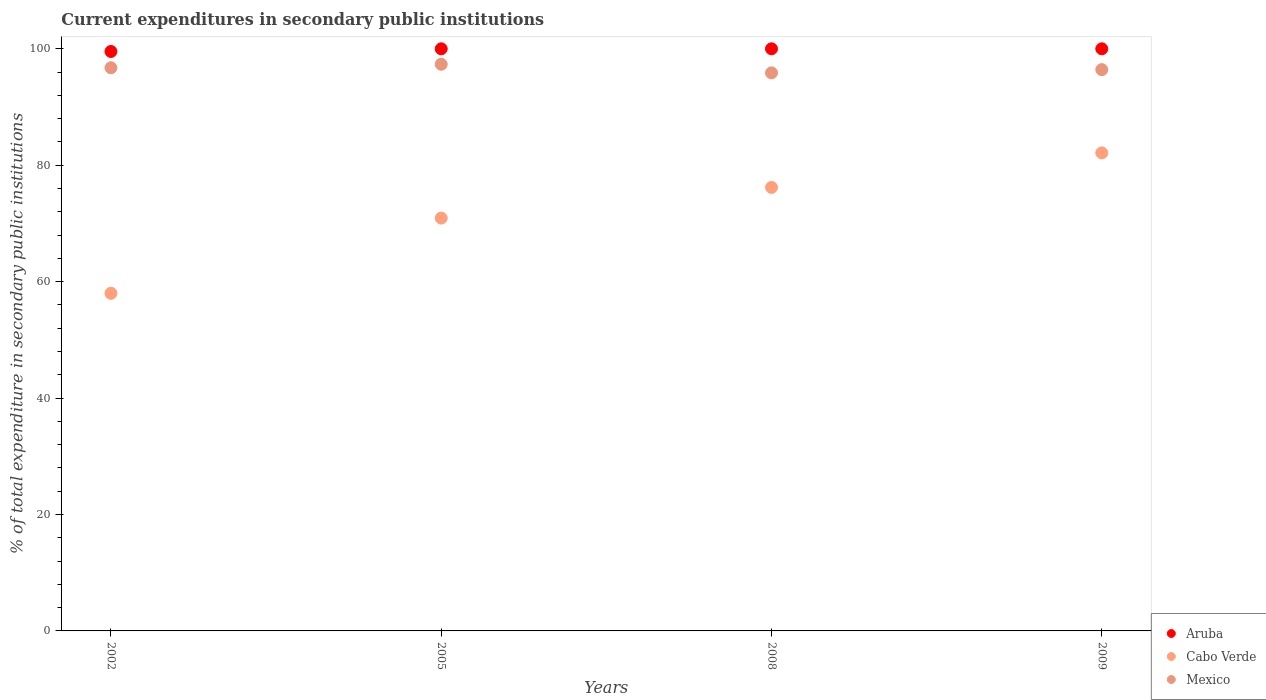Is the number of dotlines equal to the number of legend labels?
Provide a succinct answer. Yes. What is the current expenditures in secondary public institutions in Mexico in 2005?
Make the answer very short. 97.34. Across all years, what is the maximum current expenditures in secondary public institutions in Aruba?
Your response must be concise. 100. Across all years, what is the minimum current expenditures in secondary public institutions in Aruba?
Offer a terse response. 99.54. In which year was the current expenditures in secondary public institutions in Cabo Verde maximum?
Give a very brief answer. 2009. In which year was the current expenditures in secondary public institutions in Aruba minimum?
Ensure brevity in your answer.  2002. What is the total current expenditures in secondary public institutions in Cabo Verde in the graph?
Your answer should be very brief. 287.23. What is the difference between the current expenditures in secondary public institutions in Cabo Verde in 2002 and that in 2005?
Offer a terse response. -12.93. What is the difference between the current expenditures in secondary public institutions in Mexico in 2005 and the current expenditures in secondary public institutions in Cabo Verde in 2008?
Offer a very short reply. 21.16. What is the average current expenditures in secondary public institutions in Aruba per year?
Offer a terse response. 99.89. In the year 2008, what is the difference between the current expenditures in secondary public institutions in Aruba and current expenditures in secondary public institutions in Cabo Verde?
Make the answer very short. 23.81. What is the ratio of the current expenditures in secondary public institutions in Aruba in 2002 to that in 2005?
Your answer should be very brief. 1. What is the difference between the highest and the lowest current expenditures in secondary public institutions in Aruba?
Give a very brief answer. 0.46. In how many years, is the current expenditures in secondary public institutions in Aruba greater than the average current expenditures in secondary public institutions in Aruba taken over all years?
Your answer should be compact. 3. Is the sum of the current expenditures in secondary public institutions in Aruba in 2005 and 2008 greater than the maximum current expenditures in secondary public institutions in Mexico across all years?
Give a very brief answer. Yes. Is it the case that in every year, the sum of the current expenditures in secondary public institutions in Mexico and current expenditures in secondary public institutions in Cabo Verde  is greater than the current expenditures in secondary public institutions in Aruba?
Provide a short and direct response. Yes. How many years are there in the graph?
Offer a very short reply. 4. What is the difference between two consecutive major ticks on the Y-axis?
Your answer should be very brief. 20. Are the values on the major ticks of Y-axis written in scientific E-notation?
Give a very brief answer. No. Does the graph contain grids?
Provide a short and direct response. No. What is the title of the graph?
Your answer should be compact. Current expenditures in secondary public institutions. What is the label or title of the X-axis?
Offer a very short reply. Years. What is the label or title of the Y-axis?
Provide a succinct answer. % of total expenditure in secondary public institutions. What is the % of total expenditure in secondary public institutions in Aruba in 2002?
Make the answer very short. 99.54. What is the % of total expenditure in secondary public institutions in Cabo Verde in 2002?
Your answer should be compact. 58. What is the % of total expenditure in secondary public institutions in Mexico in 2002?
Offer a terse response. 96.74. What is the % of total expenditure in secondary public institutions of Aruba in 2005?
Give a very brief answer. 100. What is the % of total expenditure in secondary public institutions of Cabo Verde in 2005?
Make the answer very short. 70.92. What is the % of total expenditure in secondary public institutions of Mexico in 2005?
Offer a terse response. 97.34. What is the % of total expenditure in secondary public institutions in Cabo Verde in 2008?
Provide a succinct answer. 76.19. What is the % of total expenditure in secondary public institutions in Mexico in 2008?
Provide a short and direct response. 95.87. What is the % of total expenditure in secondary public institutions of Aruba in 2009?
Offer a very short reply. 100. What is the % of total expenditure in secondary public institutions in Cabo Verde in 2009?
Make the answer very short. 82.12. What is the % of total expenditure in secondary public institutions of Mexico in 2009?
Provide a short and direct response. 96.42. Across all years, what is the maximum % of total expenditure in secondary public institutions of Aruba?
Give a very brief answer. 100. Across all years, what is the maximum % of total expenditure in secondary public institutions of Cabo Verde?
Give a very brief answer. 82.12. Across all years, what is the maximum % of total expenditure in secondary public institutions in Mexico?
Your answer should be compact. 97.34. Across all years, what is the minimum % of total expenditure in secondary public institutions in Aruba?
Offer a terse response. 99.54. Across all years, what is the minimum % of total expenditure in secondary public institutions in Cabo Verde?
Your response must be concise. 58. Across all years, what is the minimum % of total expenditure in secondary public institutions in Mexico?
Ensure brevity in your answer.  95.87. What is the total % of total expenditure in secondary public institutions in Aruba in the graph?
Your response must be concise. 399.54. What is the total % of total expenditure in secondary public institutions in Cabo Verde in the graph?
Your answer should be compact. 287.23. What is the total % of total expenditure in secondary public institutions of Mexico in the graph?
Provide a short and direct response. 386.38. What is the difference between the % of total expenditure in secondary public institutions in Aruba in 2002 and that in 2005?
Give a very brief answer. -0.46. What is the difference between the % of total expenditure in secondary public institutions in Cabo Verde in 2002 and that in 2005?
Provide a short and direct response. -12.93. What is the difference between the % of total expenditure in secondary public institutions in Mexico in 2002 and that in 2005?
Your response must be concise. -0.6. What is the difference between the % of total expenditure in secondary public institutions in Aruba in 2002 and that in 2008?
Keep it short and to the point. -0.46. What is the difference between the % of total expenditure in secondary public institutions in Cabo Verde in 2002 and that in 2008?
Your response must be concise. -18.19. What is the difference between the % of total expenditure in secondary public institutions of Mexico in 2002 and that in 2008?
Provide a short and direct response. 0.87. What is the difference between the % of total expenditure in secondary public institutions of Aruba in 2002 and that in 2009?
Your answer should be compact. -0.46. What is the difference between the % of total expenditure in secondary public institutions of Cabo Verde in 2002 and that in 2009?
Ensure brevity in your answer.  -24.12. What is the difference between the % of total expenditure in secondary public institutions in Mexico in 2002 and that in 2009?
Your response must be concise. 0.33. What is the difference between the % of total expenditure in secondary public institutions of Cabo Verde in 2005 and that in 2008?
Give a very brief answer. -5.27. What is the difference between the % of total expenditure in secondary public institutions in Mexico in 2005 and that in 2008?
Your answer should be compact. 1.47. What is the difference between the % of total expenditure in secondary public institutions of Cabo Verde in 2005 and that in 2009?
Your answer should be compact. -11.2. What is the difference between the % of total expenditure in secondary public institutions in Mexico in 2005 and that in 2009?
Keep it short and to the point. 0.93. What is the difference between the % of total expenditure in secondary public institutions in Cabo Verde in 2008 and that in 2009?
Give a very brief answer. -5.93. What is the difference between the % of total expenditure in secondary public institutions in Mexico in 2008 and that in 2009?
Your response must be concise. -0.55. What is the difference between the % of total expenditure in secondary public institutions of Aruba in 2002 and the % of total expenditure in secondary public institutions of Cabo Verde in 2005?
Provide a succinct answer. 28.62. What is the difference between the % of total expenditure in secondary public institutions of Aruba in 2002 and the % of total expenditure in secondary public institutions of Mexico in 2005?
Make the answer very short. 2.2. What is the difference between the % of total expenditure in secondary public institutions of Cabo Verde in 2002 and the % of total expenditure in secondary public institutions of Mexico in 2005?
Offer a terse response. -39.35. What is the difference between the % of total expenditure in secondary public institutions of Aruba in 2002 and the % of total expenditure in secondary public institutions of Cabo Verde in 2008?
Offer a terse response. 23.35. What is the difference between the % of total expenditure in secondary public institutions of Aruba in 2002 and the % of total expenditure in secondary public institutions of Mexico in 2008?
Provide a succinct answer. 3.67. What is the difference between the % of total expenditure in secondary public institutions of Cabo Verde in 2002 and the % of total expenditure in secondary public institutions of Mexico in 2008?
Your answer should be compact. -37.87. What is the difference between the % of total expenditure in secondary public institutions in Aruba in 2002 and the % of total expenditure in secondary public institutions in Cabo Verde in 2009?
Offer a terse response. 17.42. What is the difference between the % of total expenditure in secondary public institutions in Aruba in 2002 and the % of total expenditure in secondary public institutions in Mexico in 2009?
Ensure brevity in your answer.  3.12. What is the difference between the % of total expenditure in secondary public institutions of Cabo Verde in 2002 and the % of total expenditure in secondary public institutions of Mexico in 2009?
Keep it short and to the point. -38.42. What is the difference between the % of total expenditure in secondary public institutions in Aruba in 2005 and the % of total expenditure in secondary public institutions in Cabo Verde in 2008?
Make the answer very short. 23.81. What is the difference between the % of total expenditure in secondary public institutions of Aruba in 2005 and the % of total expenditure in secondary public institutions of Mexico in 2008?
Provide a short and direct response. 4.13. What is the difference between the % of total expenditure in secondary public institutions in Cabo Verde in 2005 and the % of total expenditure in secondary public institutions in Mexico in 2008?
Your answer should be compact. -24.95. What is the difference between the % of total expenditure in secondary public institutions of Aruba in 2005 and the % of total expenditure in secondary public institutions of Cabo Verde in 2009?
Make the answer very short. 17.88. What is the difference between the % of total expenditure in secondary public institutions of Aruba in 2005 and the % of total expenditure in secondary public institutions of Mexico in 2009?
Provide a succinct answer. 3.58. What is the difference between the % of total expenditure in secondary public institutions in Cabo Verde in 2005 and the % of total expenditure in secondary public institutions in Mexico in 2009?
Keep it short and to the point. -25.5. What is the difference between the % of total expenditure in secondary public institutions of Aruba in 2008 and the % of total expenditure in secondary public institutions of Cabo Verde in 2009?
Your answer should be very brief. 17.88. What is the difference between the % of total expenditure in secondary public institutions in Aruba in 2008 and the % of total expenditure in secondary public institutions in Mexico in 2009?
Give a very brief answer. 3.58. What is the difference between the % of total expenditure in secondary public institutions of Cabo Verde in 2008 and the % of total expenditure in secondary public institutions of Mexico in 2009?
Provide a short and direct response. -20.23. What is the average % of total expenditure in secondary public institutions in Aruba per year?
Ensure brevity in your answer.  99.89. What is the average % of total expenditure in secondary public institutions in Cabo Verde per year?
Give a very brief answer. 71.81. What is the average % of total expenditure in secondary public institutions in Mexico per year?
Offer a terse response. 96.59. In the year 2002, what is the difference between the % of total expenditure in secondary public institutions of Aruba and % of total expenditure in secondary public institutions of Cabo Verde?
Offer a very short reply. 41.54. In the year 2002, what is the difference between the % of total expenditure in secondary public institutions in Aruba and % of total expenditure in secondary public institutions in Mexico?
Your answer should be compact. 2.8. In the year 2002, what is the difference between the % of total expenditure in secondary public institutions of Cabo Verde and % of total expenditure in secondary public institutions of Mexico?
Keep it short and to the point. -38.75. In the year 2005, what is the difference between the % of total expenditure in secondary public institutions of Aruba and % of total expenditure in secondary public institutions of Cabo Verde?
Ensure brevity in your answer.  29.08. In the year 2005, what is the difference between the % of total expenditure in secondary public institutions in Aruba and % of total expenditure in secondary public institutions in Mexico?
Offer a very short reply. 2.66. In the year 2005, what is the difference between the % of total expenditure in secondary public institutions of Cabo Verde and % of total expenditure in secondary public institutions of Mexico?
Make the answer very short. -26.42. In the year 2008, what is the difference between the % of total expenditure in secondary public institutions of Aruba and % of total expenditure in secondary public institutions of Cabo Verde?
Give a very brief answer. 23.81. In the year 2008, what is the difference between the % of total expenditure in secondary public institutions in Aruba and % of total expenditure in secondary public institutions in Mexico?
Make the answer very short. 4.13. In the year 2008, what is the difference between the % of total expenditure in secondary public institutions in Cabo Verde and % of total expenditure in secondary public institutions in Mexico?
Keep it short and to the point. -19.68. In the year 2009, what is the difference between the % of total expenditure in secondary public institutions in Aruba and % of total expenditure in secondary public institutions in Cabo Verde?
Your response must be concise. 17.88. In the year 2009, what is the difference between the % of total expenditure in secondary public institutions of Aruba and % of total expenditure in secondary public institutions of Mexico?
Keep it short and to the point. 3.58. In the year 2009, what is the difference between the % of total expenditure in secondary public institutions of Cabo Verde and % of total expenditure in secondary public institutions of Mexico?
Provide a short and direct response. -14.3. What is the ratio of the % of total expenditure in secondary public institutions in Cabo Verde in 2002 to that in 2005?
Provide a short and direct response. 0.82. What is the ratio of the % of total expenditure in secondary public institutions of Aruba in 2002 to that in 2008?
Provide a succinct answer. 1. What is the ratio of the % of total expenditure in secondary public institutions of Cabo Verde in 2002 to that in 2008?
Provide a succinct answer. 0.76. What is the ratio of the % of total expenditure in secondary public institutions in Mexico in 2002 to that in 2008?
Ensure brevity in your answer.  1.01. What is the ratio of the % of total expenditure in secondary public institutions in Aruba in 2002 to that in 2009?
Keep it short and to the point. 1. What is the ratio of the % of total expenditure in secondary public institutions of Cabo Verde in 2002 to that in 2009?
Offer a terse response. 0.71. What is the ratio of the % of total expenditure in secondary public institutions of Cabo Verde in 2005 to that in 2008?
Your answer should be compact. 0.93. What is the ratio of the % of total expenditure in secondary public institutions of Mexico in 2005 to that in 2008?
Give a very brief answer. 1.02. What is the ratio of the % of total expenditure in secondary public institutions in Aruba in 2005 to that in 2009?
Your response must be concise. 1. What is the ratio of the % of total expenditure in secondary public institutions of Cabo Verde in 2005 to that in 2009?
Your answer should be compact. 0.86. What is the ratio of the % of total expenditure in secondary public institutions of Mexico in 2005 to that in 2009?
Provide a short and direct response. 1.01. What is the ratio of the % of total expenditure in secondary public institutions of Cabo Verde in 2008 to that in 2009?
Your answer should be compact. 0.93. What is the ratio of the % of total expenditure in secondary public institutions of Mexico in 2008 to that in 2009?
Your answer should be compact. 0.99. What is the difference between the highest and the second highest % of total expenditure in secondary public institutions in Aruba?
Give a very brief answer. 0. What is the difference between the highest and the second highest % of total expenditure in secondary public institutions in Cabo Verde?
Provide a succinct answer. 5.93. What is the difference between the highest and the second highest % of total expenditure in secondary public institutions of Mexico?
Give a very brief answer. 0.6. What is the difference between the highest and the lowest % of total expenditure in secondary public institutions in Aruba?
Your answer should be compact. 0.46. What is the difference between the highest and the lowest % of total expenditure in secondary public institutions in Cabo Verde?
Offer a terse response. 24.12. What is the difference between the highest and the lowest % of total expenditure in secondary public institutions in Mexico?
Make the answer very short. 1.47. 